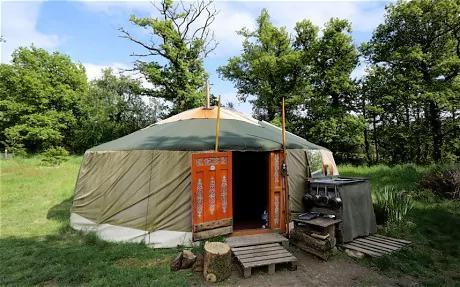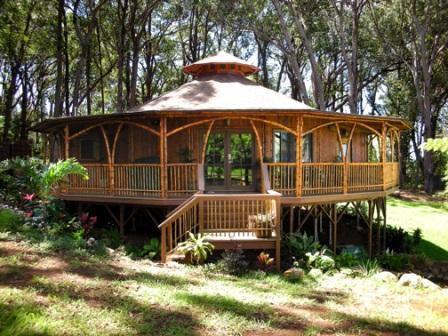The first image is the image on the left, the second image is the image on the right. For the images displayed, is the sentence "In one image, a round house has a round wrap-around porch." factually correct? Answer yes or no. Yes. The first image is the image on the left, the second image is the image on the right. For the images displayed, is the sentence "An image shows a round house on stilts surrounded by a railing and deck." factually correct? Answer yes or no. Yes. 